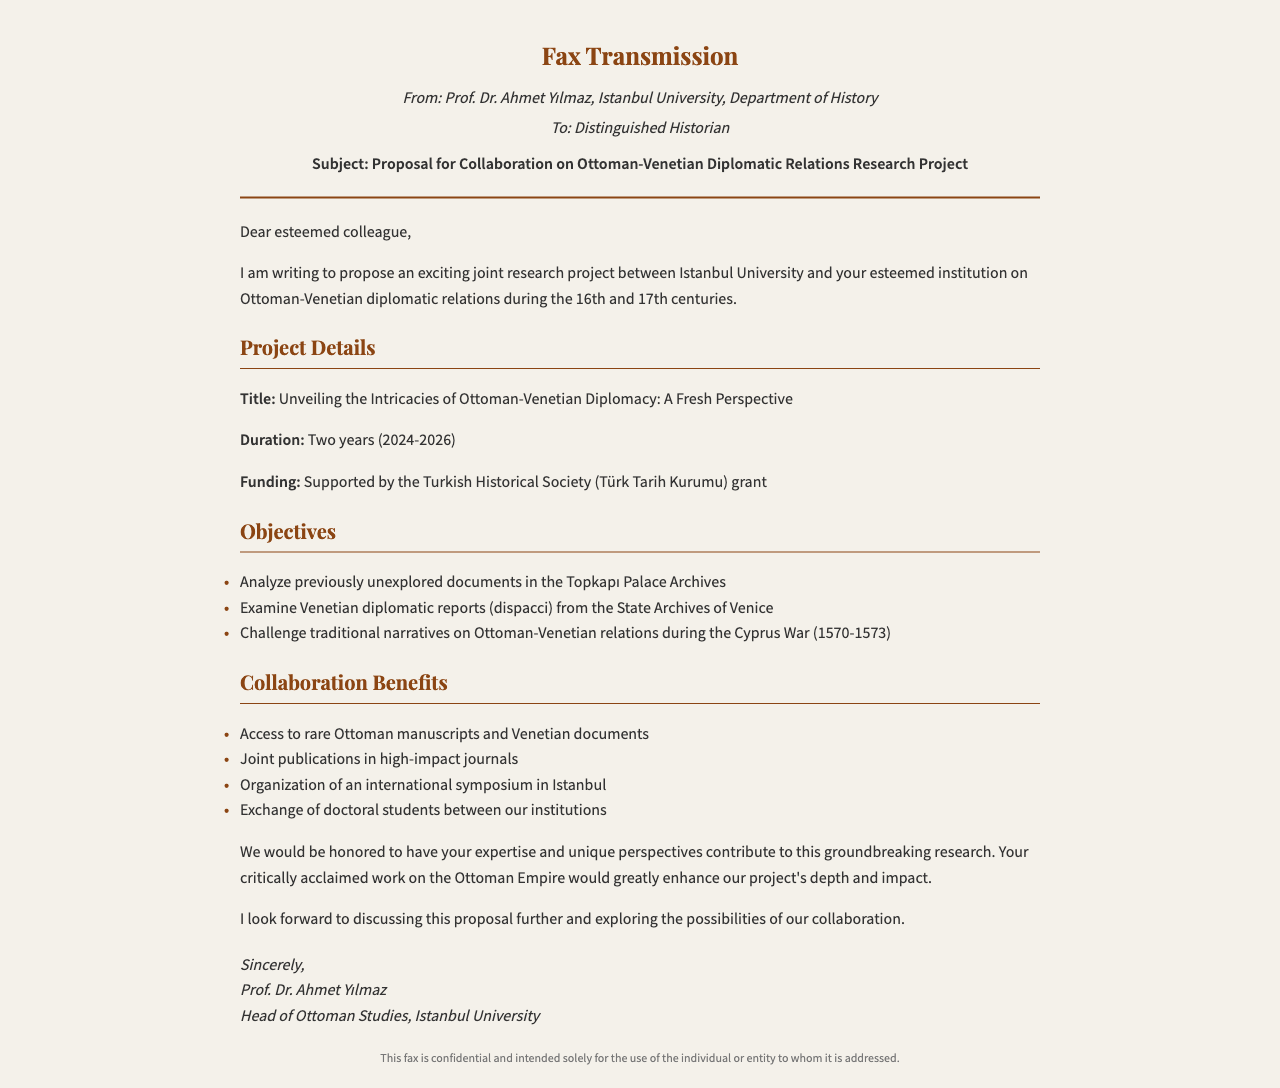What is the title of the project? The title of the project is "Unveiling the Intricacies of Ottoman-Venetian Diplomacy: A Fresh Perspective."
Answer: Unveiling the Intricacies of Ottoman-Venetian Diplomacy: A Fresh Perspective Who is the sender of the fax? The sender of the fax is Prof. Dr. Ahmet Yılmaz from Istanbul University.
Answer: Prof. Dr. Ahmet Yılmaz What is the duration of the project? The project duration is specified as two years, from 2024 to 2026.
Answer: Two years (2024-2026) Which organization is funding the project? The funding for the project is provided by the Turkish Historical Society.
Answer: Turkish Historical Society What are the two main types of diplomatic documents mentioned to be examined? The documents mentioned are Ottoman manuscripts and Venetian diplomatic reports (dispacci).
Answer: Ottoman manuscripts and Venetian diplomatic reports (dispacci) What is a proposed activity mentioned in the collaboration benefits? One of the proposed activities is the organization of an international symposium in Istanbul.
Answer: organization of an international symposium in Istanbul What specific traditional narratives are aimed to be challenged? The narratives to be challenged pertain to Ottoman-Venetian relations during the Cyprus War.
Answer: Ottoman-Venetian relations during the Cyprus War How many benefits of collaboration are listed? There are four benefits of collaboration listed in the document.
Answer: Four What style of writing does the sender use in the fax? The sender uses a formal style of writing in the fax.
Answer: Formal 